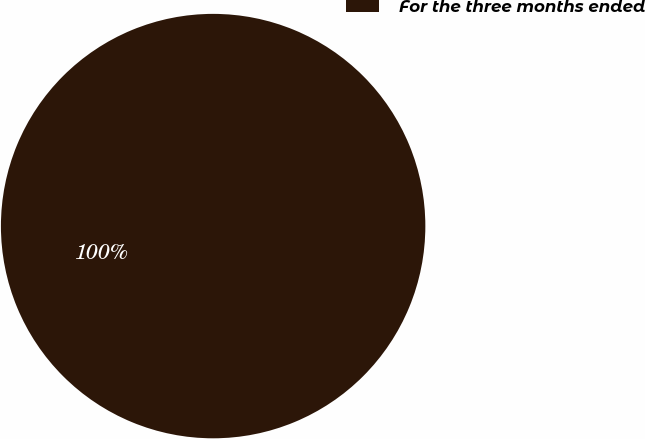Convert chart to OTSL. <chart><loc_0><loc_0><loc_500><loc_500><pie_chart><fcel>For the three months ended<nl><fcel>100.0%<nl></chart> 